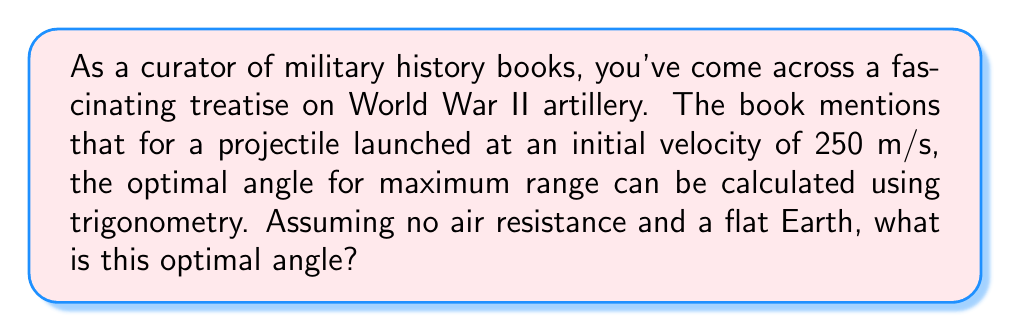Teach me how to tackle this problem. To solve this problem, we need to understand the principles of projectile motion and use trigonometry to find the optimal angle for maximum range. Here's a step-by-step explanation:

1) In projectile motion without air resistance, the range $R$ of a projectile launched at an initial velocity $v_0$ and angle $\theta$ is given by:

   $$R = \frac{v_0^2 \sin(2\theta)}{g}$$

   where $g$ is the acceleration due to gravity (9.8 m/s²).

2) To find the maximum range, we need to maximize $\sin(2\theta)$. The sine function reaches its maximum value of 1 when its argument is 90°.

3) Therefore, for maximum range:

   $$2\theta = 90°$$
   $$\theta = 45°$$

4) We can verify this mathematically by taking the derivative of the range equation with respect to $\theta$ and setting it to zero:

   $$\frac{dR}{d\theta} = \frac{v_0^2}{g} \cdot 2\cos(2\theta) = 0$$

   This is true when $\cos(2\theta) = 0$, which occurs when $2\theta = 90°$ or $\theta = 45°$.

5) This result is independent of the initial velocity, so it holds true for the given velocity of 250 m/s.

Therefore, the optimal angle for maximum range is 45°.
Answer: 45° 